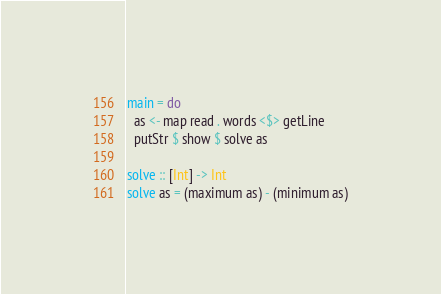<code> <loc_0><loc_0><loc_500><loc_500><_Haskell_>main = do
  as <- map read . words <$> getLine
  putStr $ show $ solve as

solve :: [Int] -> Int
solve as = (maximum as) - (minimum as)
</code> 